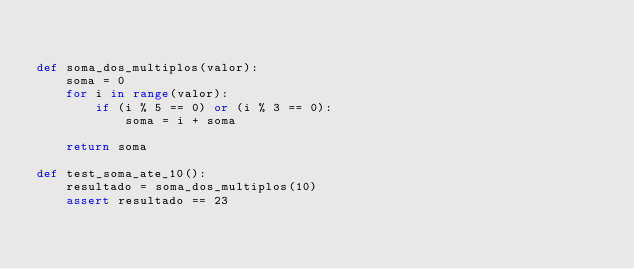Convert code to text. <code><loc_0><loc_0><loc_500><loc_500><_Python_>

def soma_dos_multiplos(valor):
    soma = 0
    for i in range(valor):
        if (i % 5 == 0) or (i % 3 == 0):
            soma = i + soma

    return soma

def test_soma_ate_10():
    resultado = soma_dos_multiplos(10)
    assert resultado == 23
</code> 